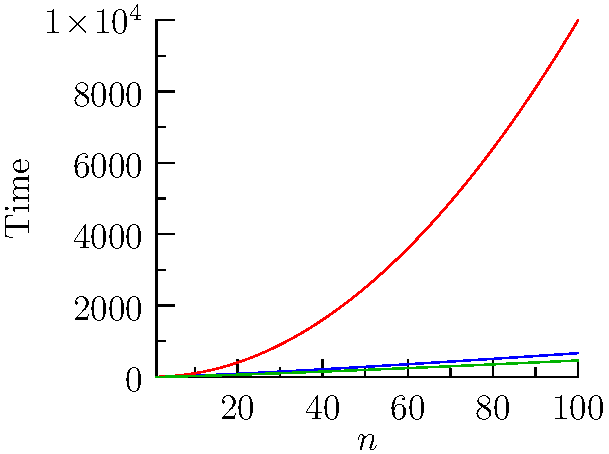Based on the time complexity graphs shown for different sorting algorithms, which algorithm would be most efficient for sorting large datasets with $n > 1000$ elements? Justify your answer considering the asymptotic behavior of the algorithms. To determine the most efficient algorithm for large datasets, we need to analyze the asymptotic behavior of each algorithm:

1. Blue curve ($n\log_2 n$): Represents Merge Sort
2. Red curve ($n^2$): Represents Bubble Sort
3. Green curve ($n\ln n$): Represents Heapsort

Step 1: Analyze asymptotic growth
- Merge Sort: $O(n\log_2 n)$
- Bubble Sort: $O(n^2)$
- Heapsort: $O(n\ln n)$

Step 2: Compare growth rates for large n
As $n$ increases, $n^2$ grows much faster than $n\log n$ or $n\ln n$.

Step 3: Compare Merge Sort and Heapsort
$\log_2 n$ and $\ln n$ differ only by a constant factor, so their asymptotic behavior is the same.

Step 4: Consider practical implications
For very large datasets ($n > 1000$), the difference between $\log_2 n$ and $\ln n$ becomes negligible.

Step 5: Conclusion
Merge Sort and Heapsort have the same asymptotic time complexity and are both significantly more efficient than Bubble Sort for large datasets. However, Heapsort ($n\ln n$) has a slightly lower constant factor than Merge Sort ($n\log_2 n$), making it marginally more efficient in practice.
Answer: Heapsort, due to its $O(n\ln n)$ time complexity and lower constant factor. 